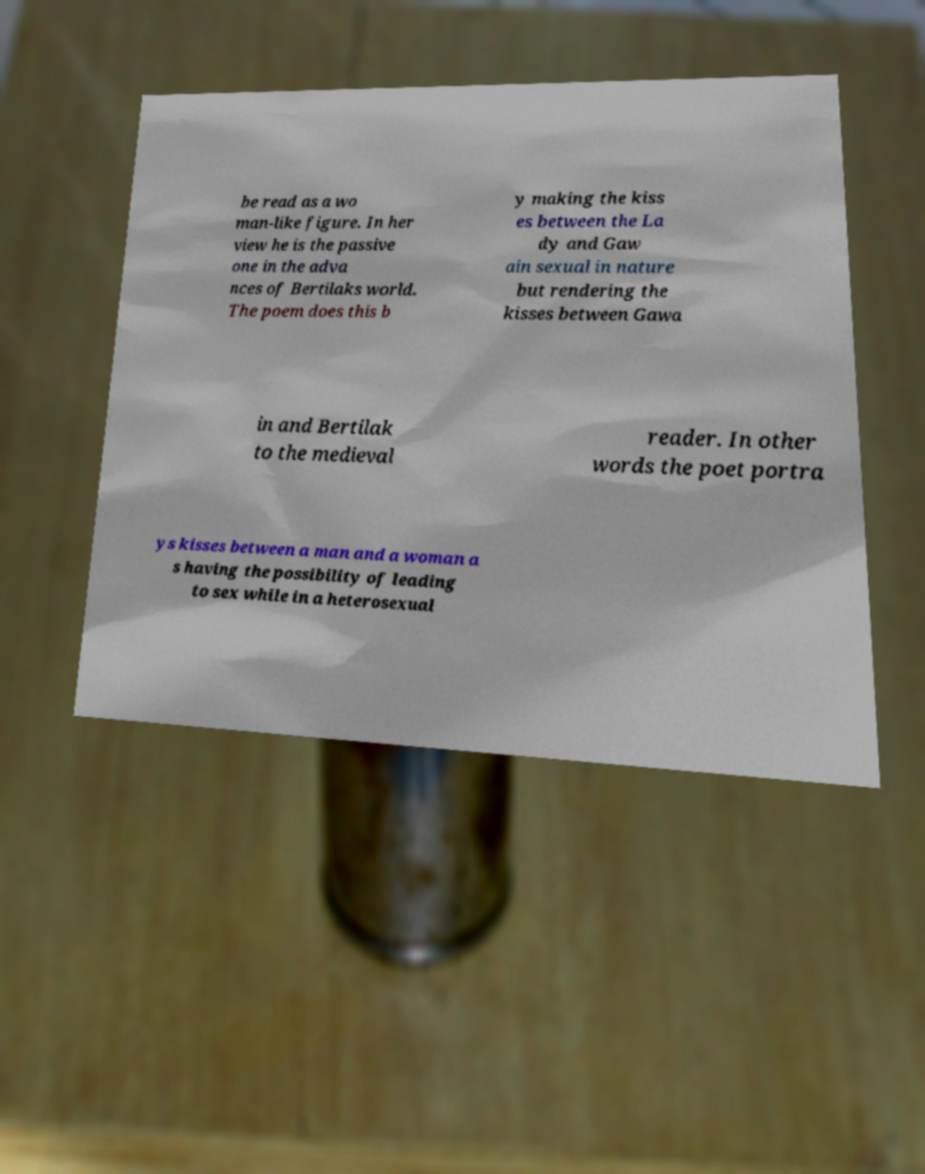Can you accurately transcribe the text from the provided image for me? be read as a wo man-like figure. In her view he is the passive one in the adva nces of Bertilaks world. The poem does this b y making the kiss es between the La dy and Gaw ain sexual in nature but rendering the kisses between Gawa in and Bertilak to the medieval reader. In other words the poet portra ys kisses between a man and a woman a s having the possibility of leading to sex while in a heterosexual 